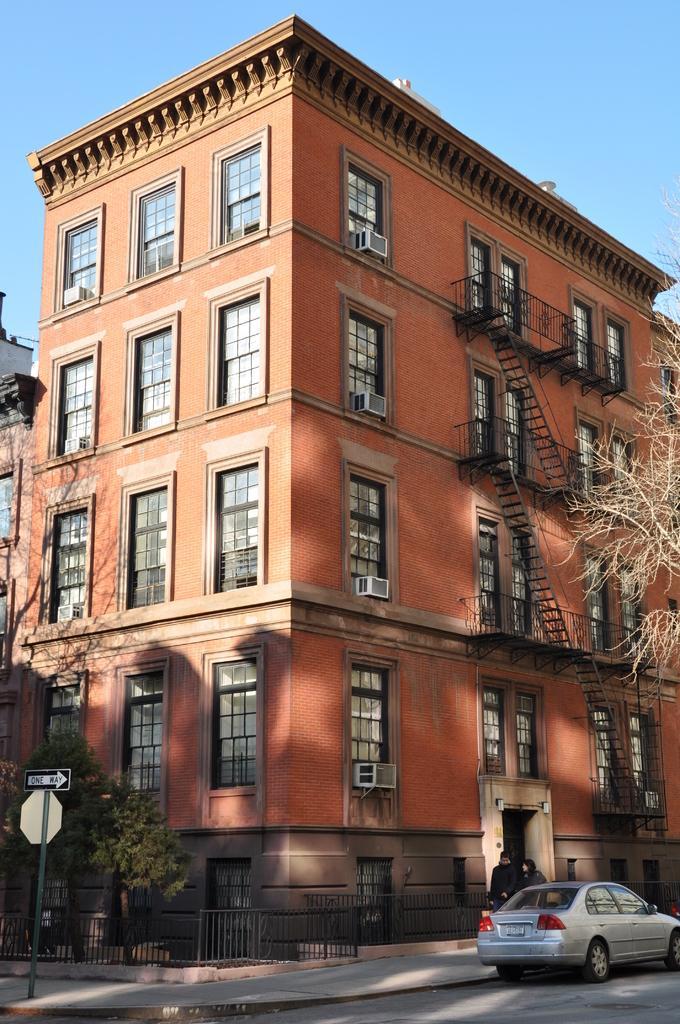Can you describe this image briefly? In this picture I can see the buildings and trees. In bottom right I can see two persons who are walking on the road, beside them I can see the car. On the left I can see the sign board. Beside that I can see the plants and fencing. At the top I can see the sky. 